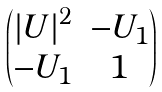<formula> <loc_0><loc_0><loc_500><loc_500>\begin{pmatrix} { | U | } ^ { 2 } & - U _ { 1 } \\ - U _ { 1 } & 1 \end{pmatrix}</formula> 